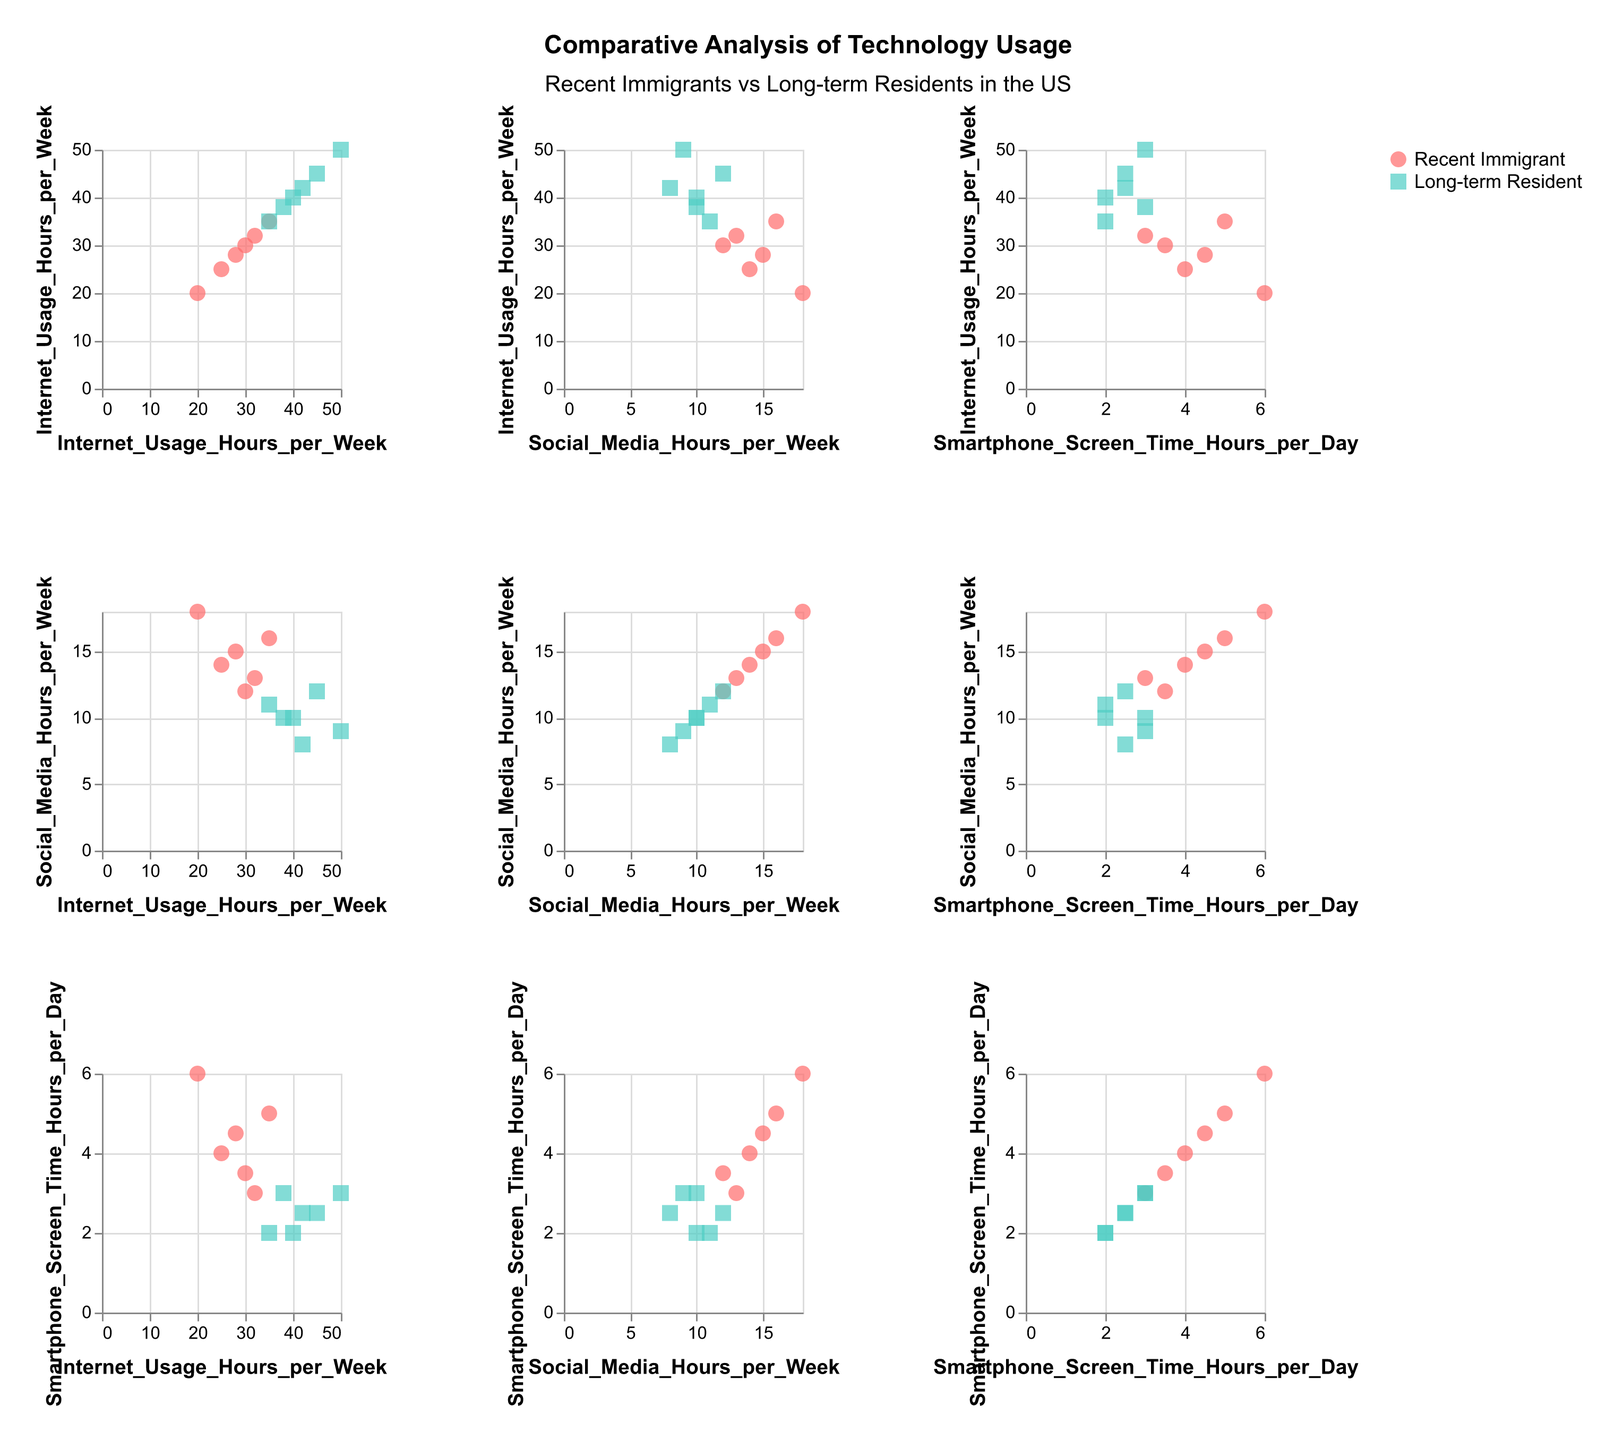What is the title of the figure? The title of the figure is usually located at the top of the graphic and provides an overview of what the figure represents.
Answer: Comparative Analysis of Technology Usage How many data points are there for each group? There are 12 data points in total, with 6 data points for "Recent Immigrant" and 6 data points for "Long-term Resident." These can be counted based on the scatter plot points.
Answer: 6 for each group Which group has a higher average Internet usage per week? For Recent Immigrants, sum their Internet usage (25 + 30 + 35 + 20 + 28 + 32) = 170 and divide by 6. For Long-term Residents, sum their Internet usage (40 + 45 + 50 + 35 + 42 + 38) = 250 and divide by 6. Compare the averages of both groups.
Answer: Long-term Residents Is there a noticeable trend between Internet usage and smartphone screen time within any group? By observing the scatter plots in the SPLOM, particularly those where Internet usage and smartphone screen time are on the axes, we can see if the points form a discernible pattern or correlation for each group.
Answer: No strong trend Do recent immigrants or long-term residents spend more time on social media on average? Calculate the average Social Media Hours per Week for Recent Immigrants and Long-term Residents, then compare. For Recent Immigrants: (14 + 12 + 16 + 18 + 15 + 13)/6 = 14.67; for Long-term Residents: (10 + 12 + 9 + 11 + 8 + 10)/6 = 10.
Answer: Recent Immigrants In which group is the variability in smartphone screen time higher? Examine the scatter plots for the smartphone screen time across both groups and assess the spread of the data points to evaluate variability visually.
Answer: Recent Immigrants Which axis is Social Media Hours per Week usually plotted on in the SPLOM? The visual layout typically has this variable plotted along either the x-axis or the y-axis to enable comparison with Internet usage and smartphone screen time.
Answer: Both x and y What is the range of Internet usage hours per week for long-term residents? Identify the minimum and maximum Internet usage hours per week for long-term residents from the data points in the scatter plot matrix.
Answer: 35 to 50 Compare the highest smartphone screen time between the two groups. Which one has a higher value? Look at the smartphone screen time values for both groups and compare the highest value in each. For Recent Immigrants, the highest is 6 hours; for Long-term Residents, the highest is 3 hours.
Answer: Recent Immigrants Are there any outliers in social media usage for long-term residents? Outliers can be identified by points that are significantly different from the rest of the data. Examine the scatter plots for Social Media Hours per Week for Long-term Residents to see if any values deviate significantly.
Answer: No outliers 